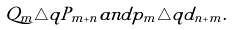<formula> <loc_0><loc_0><loc_500><loc_500>Q _ { m } \triangle q P _ { m + n } a n d p _ { m } \triangle q d _ { n + m } .</formula> 